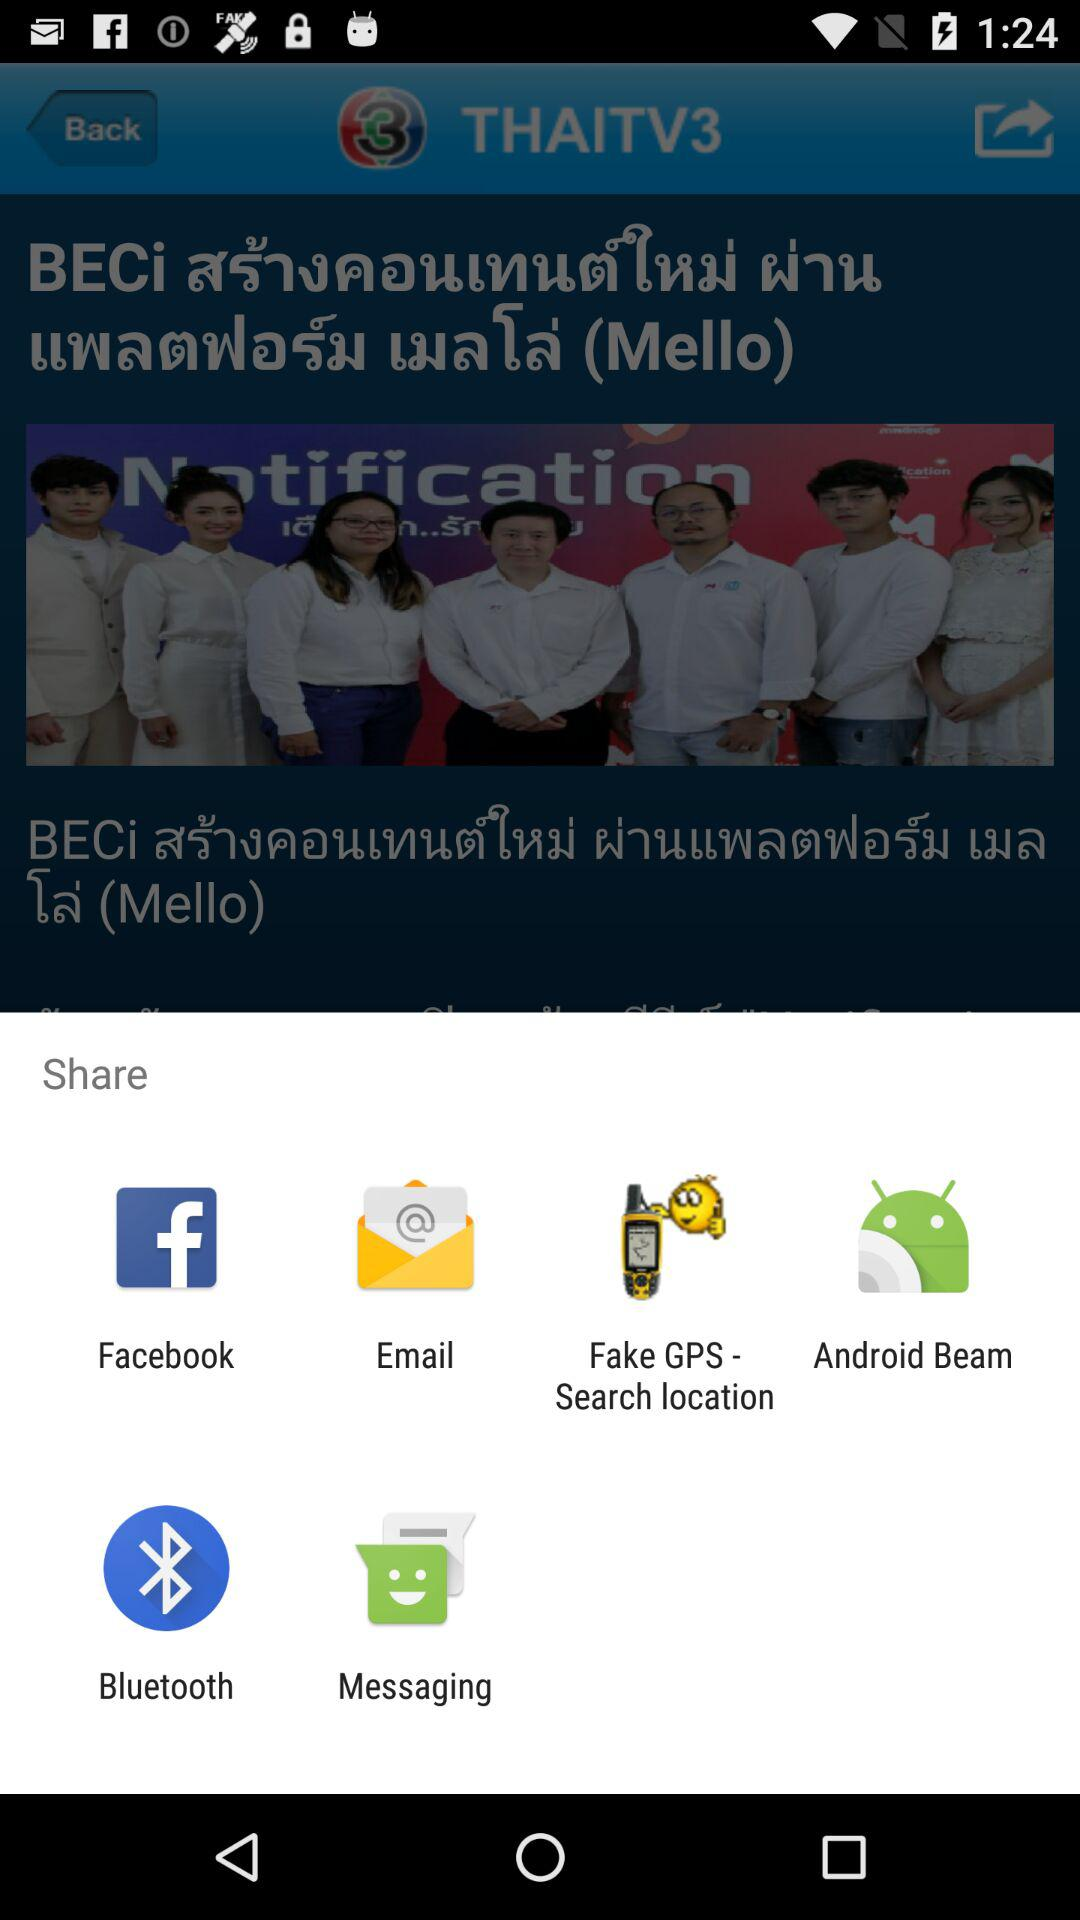What are the different options available to share the content? The different available options are "Facebook", "Email", "Fake GPS - Search location", "Android Beam", "Bluetooth" and "Messaging". 